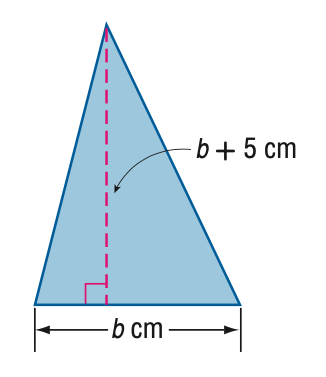Answer the mathemtical geometry problem and directly provide the correct option letter.
Question: The height of a triangle is 5 centimeters more than its base. The area of the triangle is 52 square centimeters. Find the base.
Choices: A: 5.1 B: 8 C: 9.9 D: 13 B 